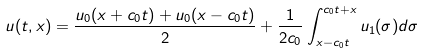Convert formula to latex. <formula><loc_0><loc_0><loc_500><loc_500>u ( t , x ) = \frac { u _ { 0 } ( x + c _ { 0 } t ) + u _ { 0 } ( x - c _ { 0 } t ) } { 2 } + \frac { 1 } { 2 c _ { 0 } } \int _ { x - c _ { 0 } t } ^ { c _ { 0 } t + x } u _ { 1 } ( \sigma ) d \sigma</formula> 